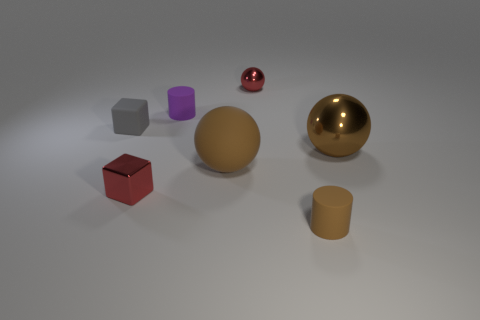What material is the sphere that is the same color as the large matte thing?
Provide a short and direct response. Metal. There is a rubber object right of the red sphere; does it have the same shape as the red metallic thing behind the tiny gray rubber object?
Offer a very short reply. No. There is a cylinder that is the same size as the purple object; what is it made of?
Keep it short and to the point. Rubber. Are the red thing that is behind the tiny metallic cube and the big ball behind the large matte object made of the same material?
Offer a terse response. Yes. There is a gray object that is the same size as the brown matte cylinder; what shape is it?
Offer a terse response. Cube. What number of other things are there of the same color as the matte ball?
Give a very brief answer. 2. There is a sphere that is behind the purple object; what color is it?
Your answer should be compact. Red. How many other objects are the same material as the purple thing?
Your answer should be very brief. 3. Is the number of small brown things in front of the tiny brown object greater than the number of blocks behind the brown shiny object?
Give a very brief answer. No. What number of large brown rubber objects are left of the big brown matte sphere?
Your answer should be compact. 0. 